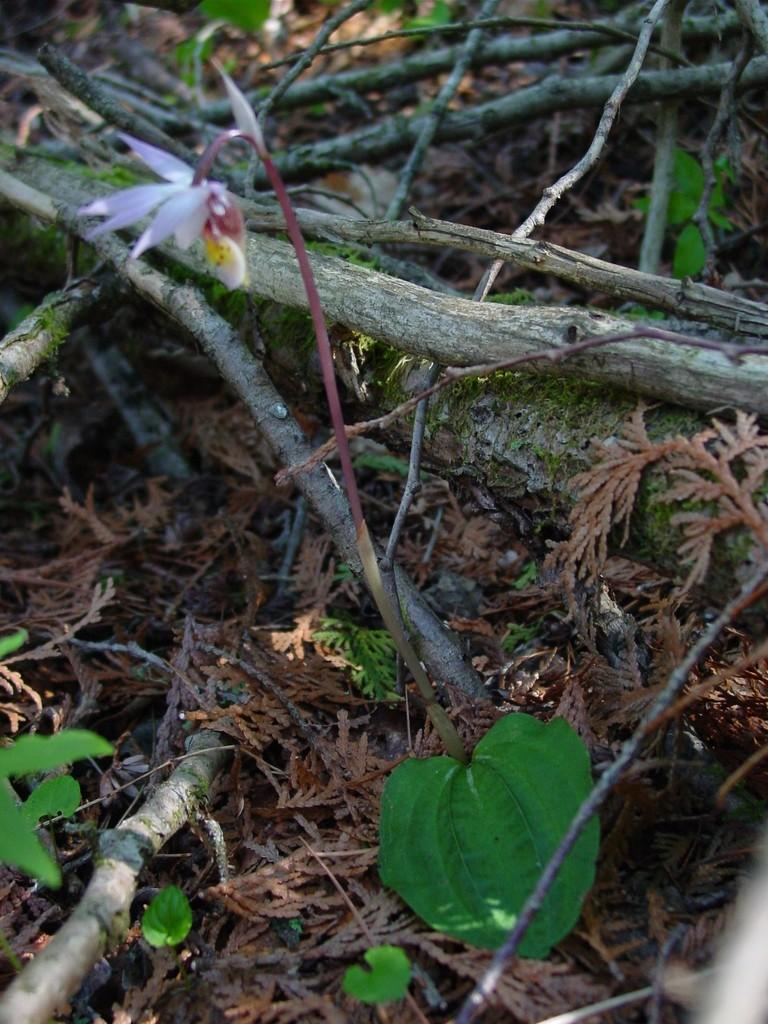What type of living organisms can be seen in the image? Plants and a flower are visible in the image. Can you describe the flower in the image? There is a flower in the image, but its specific characteristics are not mentioned in the facts. What parts of the plants are on the ground in the image? Leaves and stems are present on the ground in the image. What type of watch can be seen on the mountain in the image? There is no mountain or watch present in the image. How many rings are visible on the flower in the image? The facts do not mention any rings on the flower in the image. 